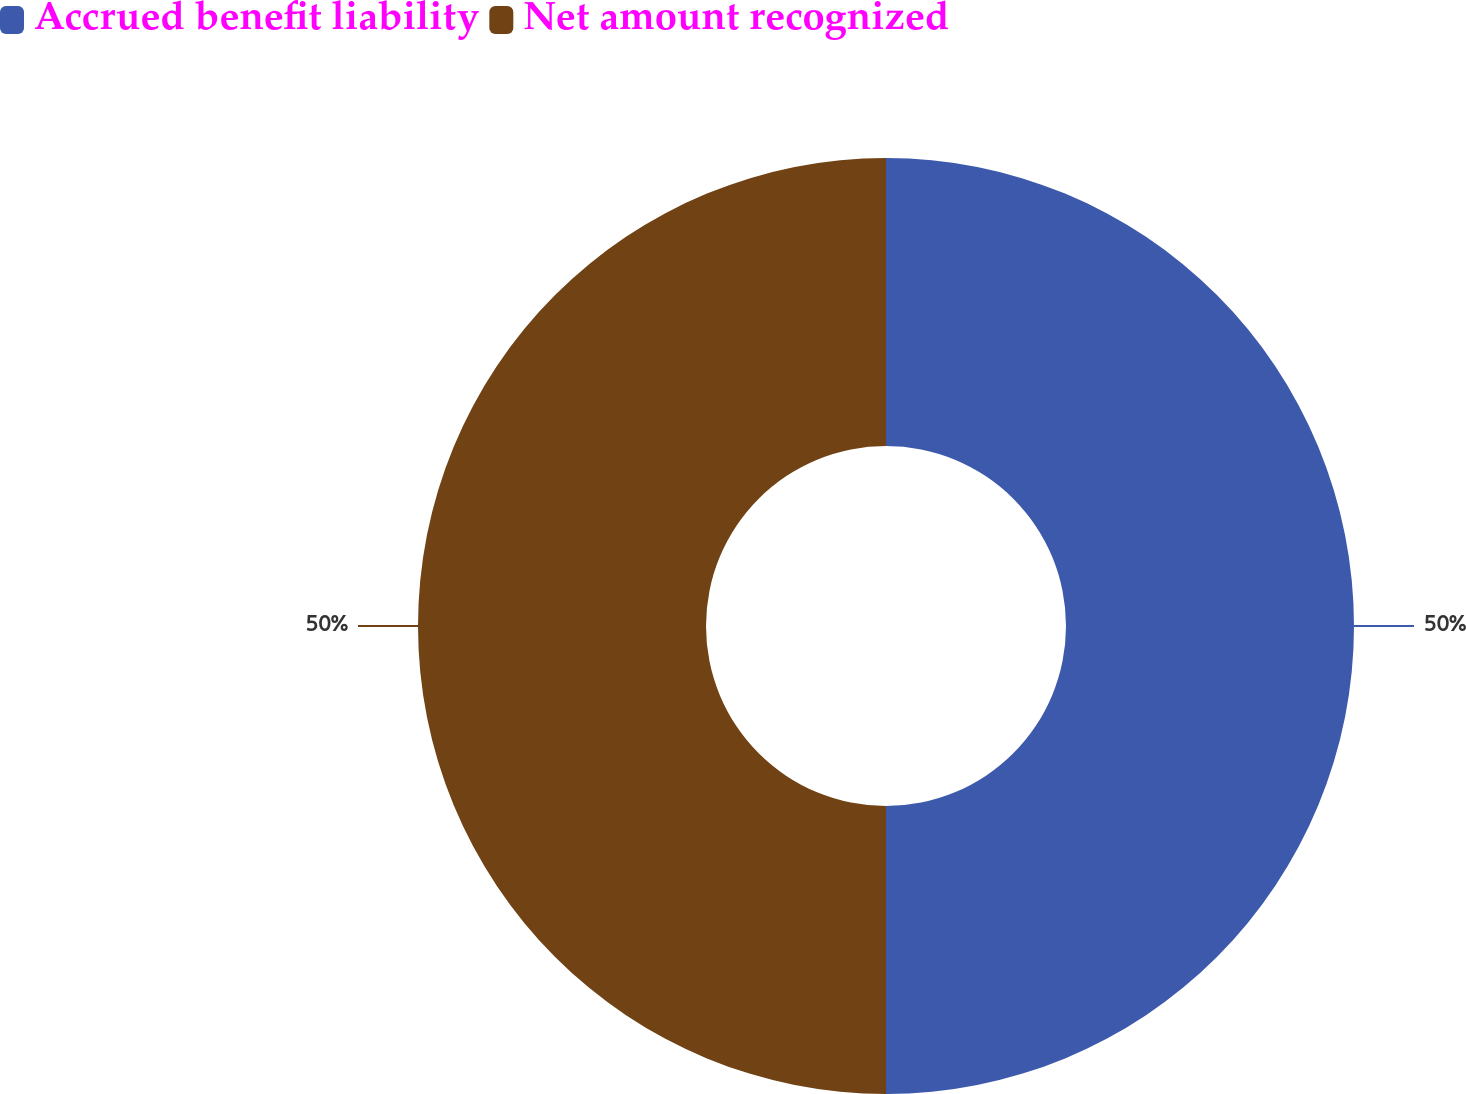<chart> <loc_0><loc_0><loc_500><loc_500><pie_chart><fcel>Accrued benefit liability<fcel>Net amount recognized<nl><fcel>50.0%<fcel>50.0%<nl></chart> 